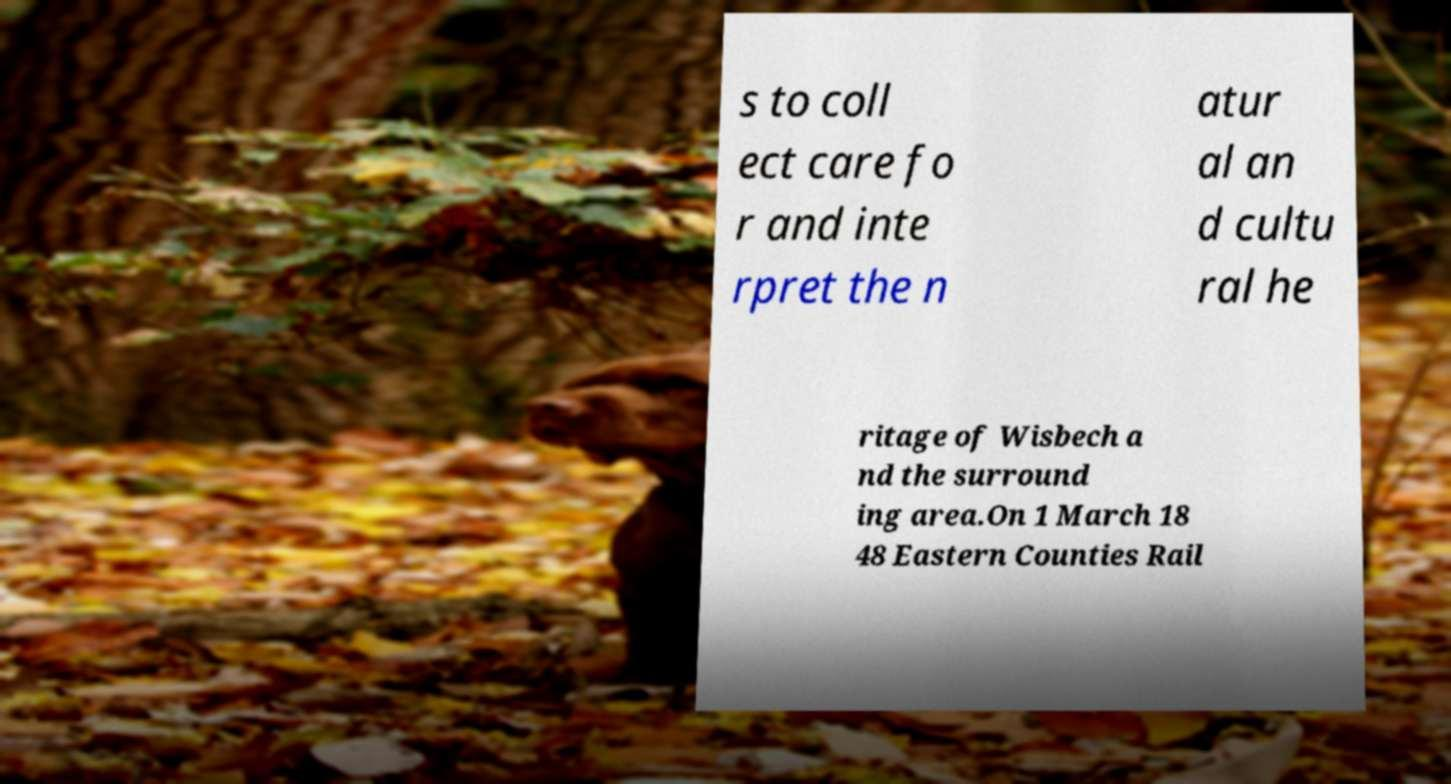There's text embedded in this image that I need extracted. Can you transcribe it verbatim? s to coll ect care fo r and inte rpret the n atur al an d cultu ral he ritage of Wisbech a nd the surround ing area.On 1 March 18 48 Eastern Counties Rail 